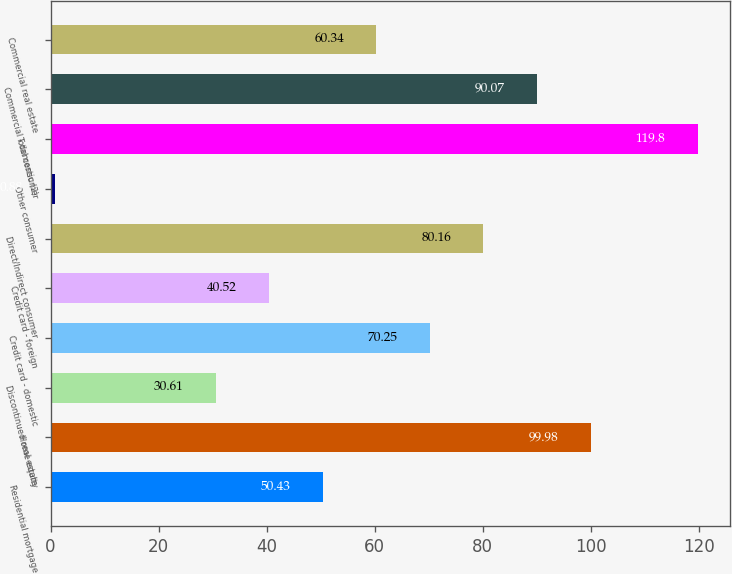<chart> <loc_0><loc_0><loc_500><loc_500><bar_chart><fcel>Residential mortgage<fcel>Home equity<fcel>Discontinued real estate<fcel>Credit card - domestic<fcel>Credit card - foreign<fcel>Direct/Indirect consumer<fcel>Other consumer<fcel>Total consumer<fcel>Commercial - domestic (2)<fcel>Commercial real estate<nl><fcel>50.43<fcel>99.98<fcel>30.61<fcel>70.25<fcel>40.52<fcel>80.16<fcel>0.88<fcel>119.8<fcel>90.07<fcel>60.34<nl></chart> 